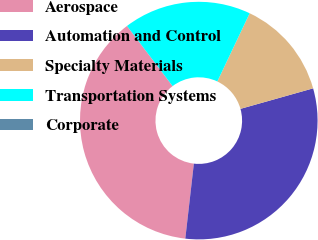Convert chart. <chart><loc_0><loc_0><loc_500><loc_500><pie_chart><fcel>Aerospace<fcel>Automation and Control<fcel>Specialty Materials<fcel>Transportation Systems<fcel>Corporate<nl><fcel>37.86%<fcel>31.19%<fcel>13.58%<fcel>17.37%<fcel>0.01%<nl></chart> 